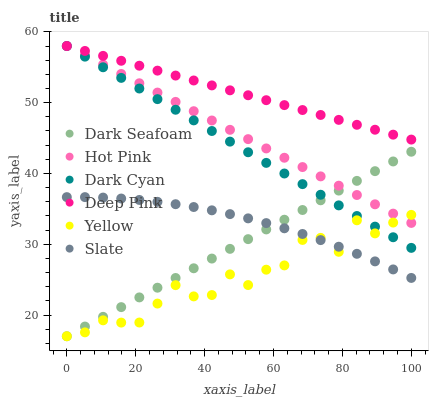Does Yellow have the minimum area under the curve?
Answer yes or no. Yes. Does Deep Pink have the maximum area under the curve?
Answer yes or no. Yes. Does Slate have the minimum area under the curve?
Answer yes or no. No. Does Slate have the maximum area under the curve?
Answer yes or no. No. Is Dark Cyan the smoothest?
Answer yes or no. Yes. Is Yellow the roughest?
Answer yes or no. Yes. Is Slate the smoothest?
Answer yes or no. No. Is Slate the roughest?
Answer yes or no. No. Does Yellow have the lowest value?
Answer yes or no. Yes. Does Slate have the lowest value?
Answer yes or no. No. Does Dark Cyan have the highest value?
Answer yes or no. Yes. Does Slate have the highest value?
Answer yes or no. No. Is Dark Seafoam less than Deep Pink?
Answer yes or no. Yes. Is Deep Pink greater than Slate?
Answer yes or no. Yes. Does Yellow intersect Slate?
Answer yes or no. Yes. Is Yellow less than Slate?
Answer yes or no. No. Is Yellow greater than Slate?
Answer yes or no. No. Does Dark Seafoam intersect Deep Pink?
Answer yes or no. No. 